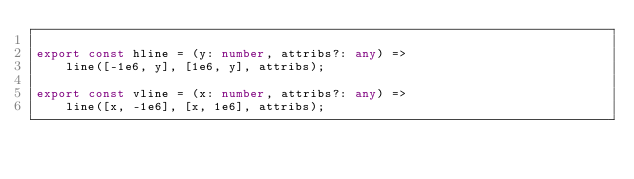Convert code to text. <code><loc_0><loc_0><loc_500><loc_500><_TypeScript_>
export const hline = (y: number, attribs?: any) =>
    line([-1e6, y], [1e6, y], attribs);

export const vline = (x: number, attribs?: any) =>
    line([x, -1e6], [x, 1e6], attribs);
</code> 